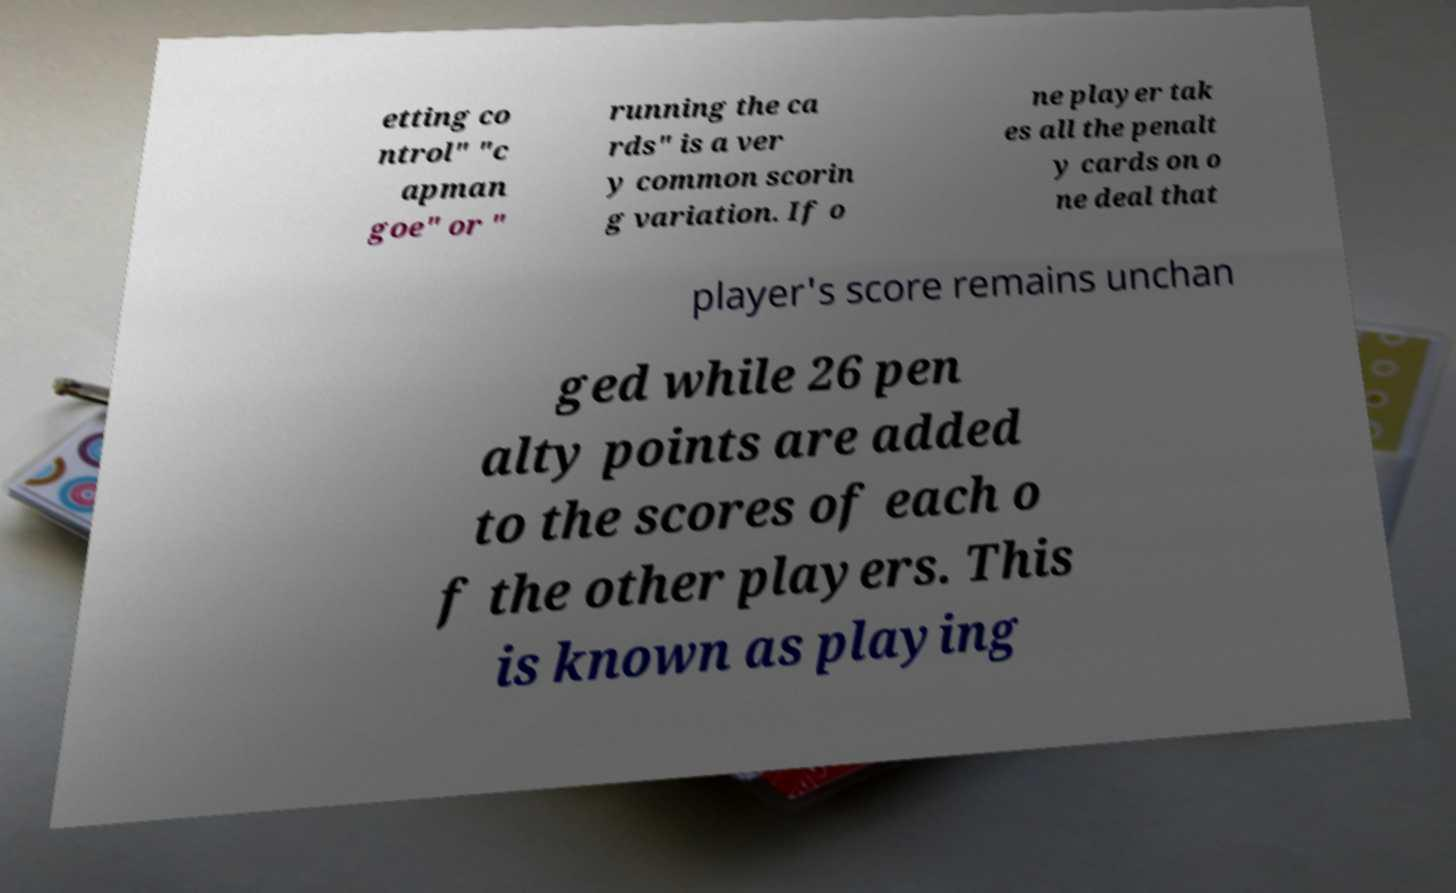Please identify and transcribe the text found in this image. etting co ntrol" "c apman goe" or " running the ca rds" is a ver y common scorin g variation. If o ne player tak es all the penalt y cards on o ne deal that player's score remains unchan ged while 26 pen alty points are added to the scores of each o f the other players. This is known as playing 